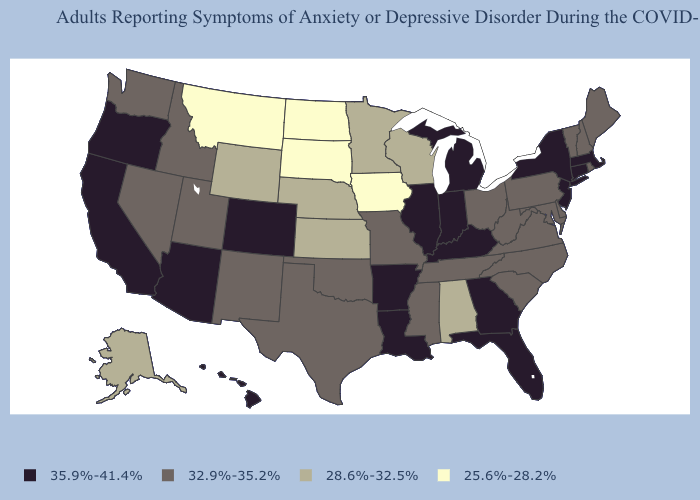Does Washington have the same value as Virginia?
Concise answer only. Yes. Does Louisiana have a higher value than Mississippi?
Answer briefly. Yes. What is the value of Illinois?
Give a very brief answer. 35.9%-41.4%. Does the map have missing data?
Keep it brief. No. Name the states that have a value in the range 32.9%-35.2%?
Answer briefly. Delaware, Idaho, Maine, Maryland, Mississippi, Missouri, Nevada, New Hampshire, New Mexico, North Carolina, Ohio, Oklahoma, Pennsylvania, Rhode Island, South Carolina, Tennessee, Texas, Utah, Vermont, Virginia, Washington, West Virginia. What is the highest value in states that border Delaware?
Answer briefly. 35.9%-41.4%. Name the states that have a value in the range 28.6%-32.5%?
Answer briefly. Alabama, Alaska, Kansas, Minnesota, Nebraska, Wisconsin, Wyoming. Does Nevada have a lower value than Illinois?
Quick response, please. Yes. Name the states that have a value in the range 32.9%-35.2%?
Short answer required. Delaware, Idaho, Maine, Maryland, Mississippi, Missouri, Nevada, New Hampshire, New Mexico, North Carolina, Ohio, Oklahoma, Pennsylvania, Rhode Island, South Carolina, Tennessee, Texas, Utah, Vermont, Virginia, Washington, West Virginia. Which states have the highest value in the USA?
Concise answer only. Arizona, Arkansas, California, Colorado, Connecticut, Florida, Georgia, Hawaii, Illinois, Indiana, Kentucky, Louisiana, Massachusetts, Michigan, New Jersey, New York, Oregon. What is the value of Louisiana?
Be succinct. 35.9%-41.4%. What is the value of Michigan?
Write a very short answer. 35.9%-41.4%. What is the highest value in states that border Massachusetts?
Be succinct. 35.9%-41.4%. Does the map have missing data?
Short answer required. No. What is the value of Arkansas?
Be succinct. 35.9%-41.4%. 